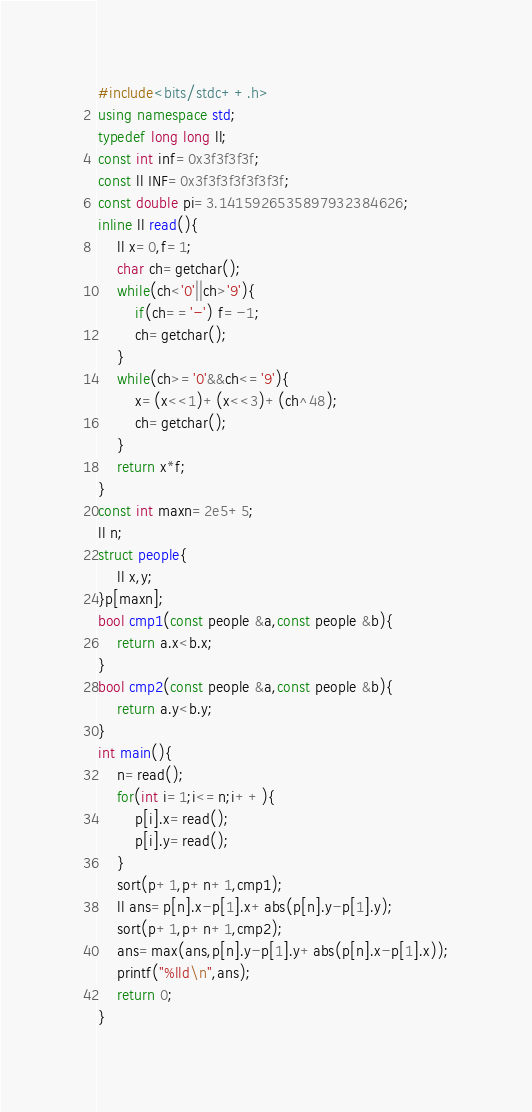Convert code to text. <code><loc_0><loc_0><loc_500><loc_500><_C++_>#include<bits/stdc++.h>
using namespace std;
typedef long long ll;
const int inf=0x3f3f3f3f;
const ll INF=0x3f3f3f3f3f3f3f;
const double pi=3.1415926535897932384626;
inline ll read(){
	ll x=0,f=1;
	char ch=getchar();
	while(ch<'0'||ch>'9'){
		if(ch=='-') f=-1;
		ch=getchar();
	}
	while(ch>='0'&&ch<='9'){
		x=(x<<1)+(x<<3)+(ch^48);
		ch=getchar();
	}
	return x*f;
}
const int maxn=2e5+5;
ll n;
struct people{
    ll x,y;
}p[maxn];
bool cmp1(const people &a,const people &b){
    return a.x<b.x;
}
bool cmp2(const people &a,const people &b){
    return a.y<b.y;
}
int main(){
    n=read();
    for(int i=1;i<=n;i++){
        p[i].x=read();
        p[i].y=read();
    }
    sort(p+1,p+n+1,cmp1);
    ll ans=p[n].x-p[1].x+abs(p[n].y-p[1].y);
    sort(p+1,p+n+1,cmp2);
    ans=max(ans,p[n].y-p[1].y+abs(p[n].x-p[1].x));
    printf("%lld\n",ans);
	return 0;
}
</code> 